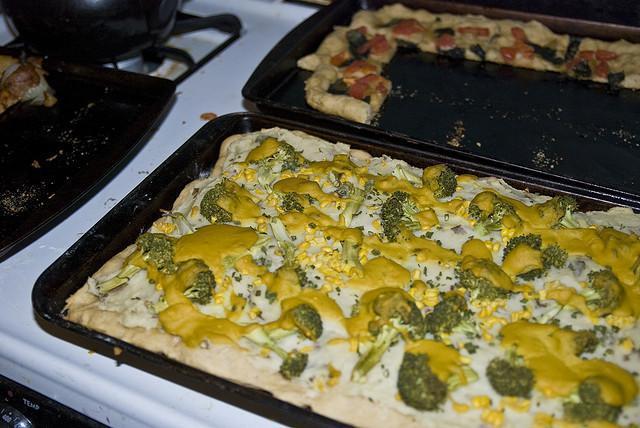How many pans are there?
Give a very brief answer. 3. How many broccolis are visible?
Give a very brief answer. 3. How many pizzas are visible?
Give a very brief answer. 3. 